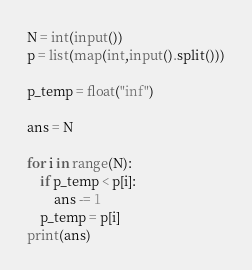<code> <loc_0><loc_0><loc_500><loc_500><_Python_>N = int(input())
p = list(map(int,input().split()))

p_temp = float("inf")

ans = N

for i in range(N):
	if p_temp < p[i]:
		ans -= 1
	p_temp = p[i]
print(ans)
</code> 